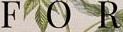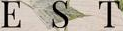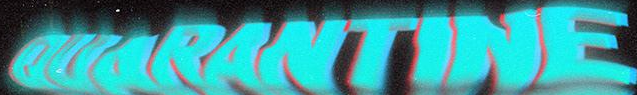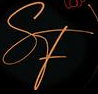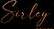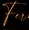What text is displayed in these images sequentially, separated by a semicolon? FOR; EST; OUARANTINE; SF; Suley; Fu 